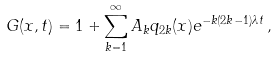<formula> <loc_0><loc_0><loc_500><loc_500>G ( x , t ) = 1 + \sum _ { k = 1 } ^ { \infty } A _ { k } q _ { 2 k } ( x ) e ^ { - k ( 2 k - 1 ) \lambda t } \, ,</formula> 